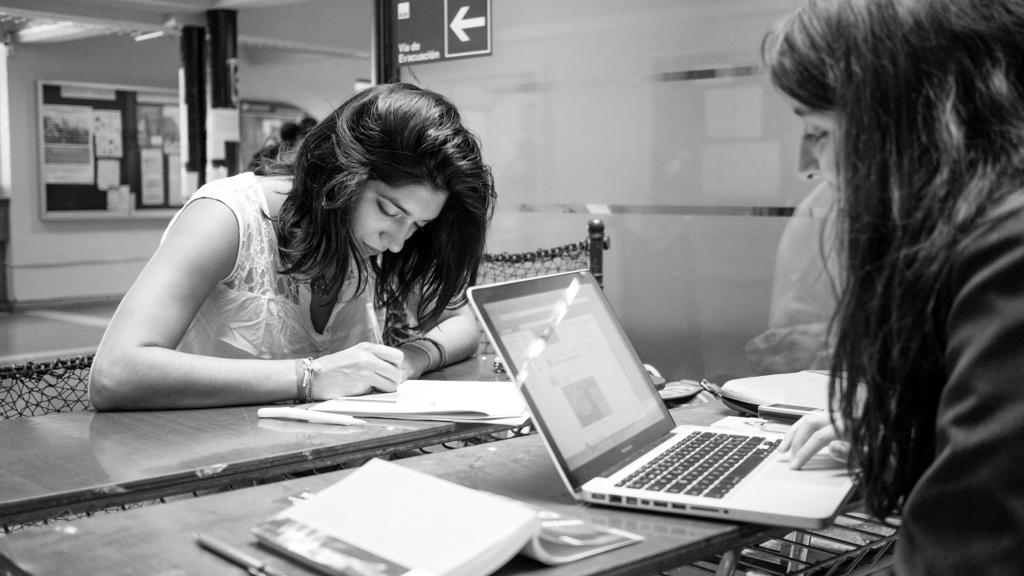What is the color scheme of the image? The image is black and white. What type of furniture can be seen in the image? There are tables in the image. What are the people in the image doing? People are sitting at the tables. What is located on the left side of the image? There is a board on the left side of the image. What items can be seen on the tables? Books, laptops, and papers are present on the tables. What type of slope can be seen in the image? There is no slope present in the image. What government-related activity is taking place in the image? There is no indication of any government-related activity in the image. 